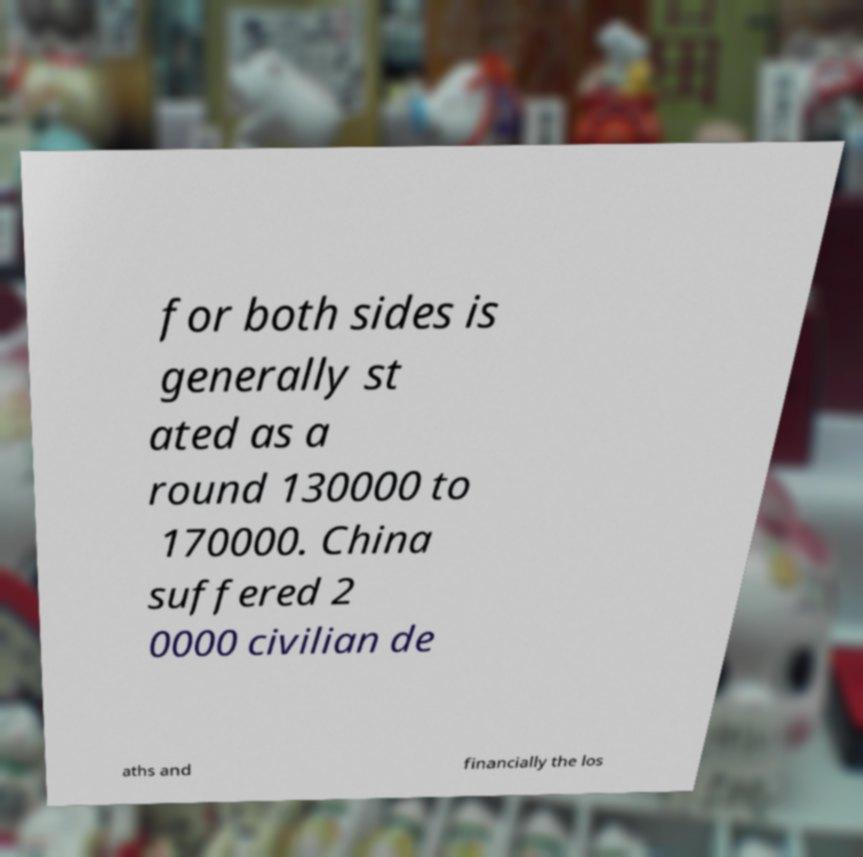Please read and relay the text visible in this image. What does it say? for both sides is generally st ated as a round 130000 to 170000. China suffered 2 0000 civilian de aths and financially the los 